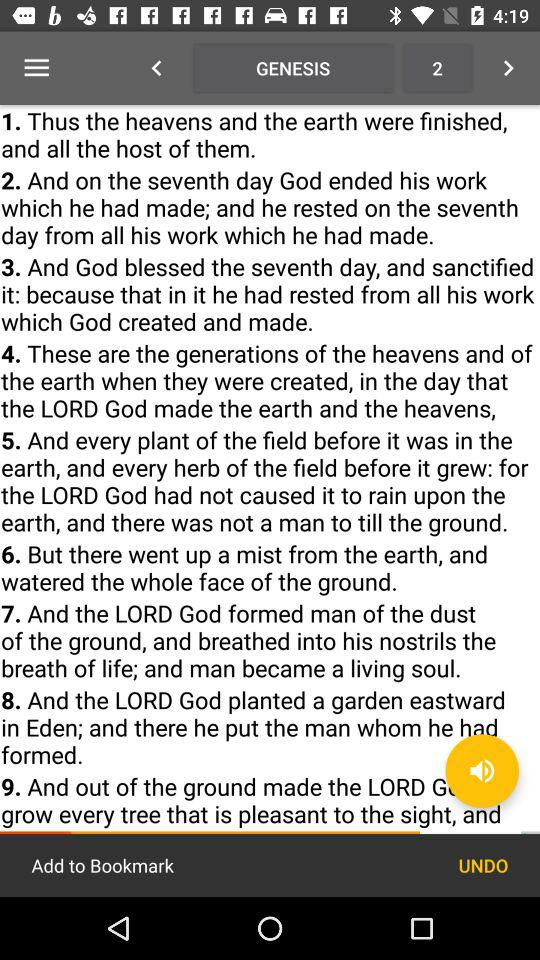On which day did God end the work? God ended the work on the seventh day. 